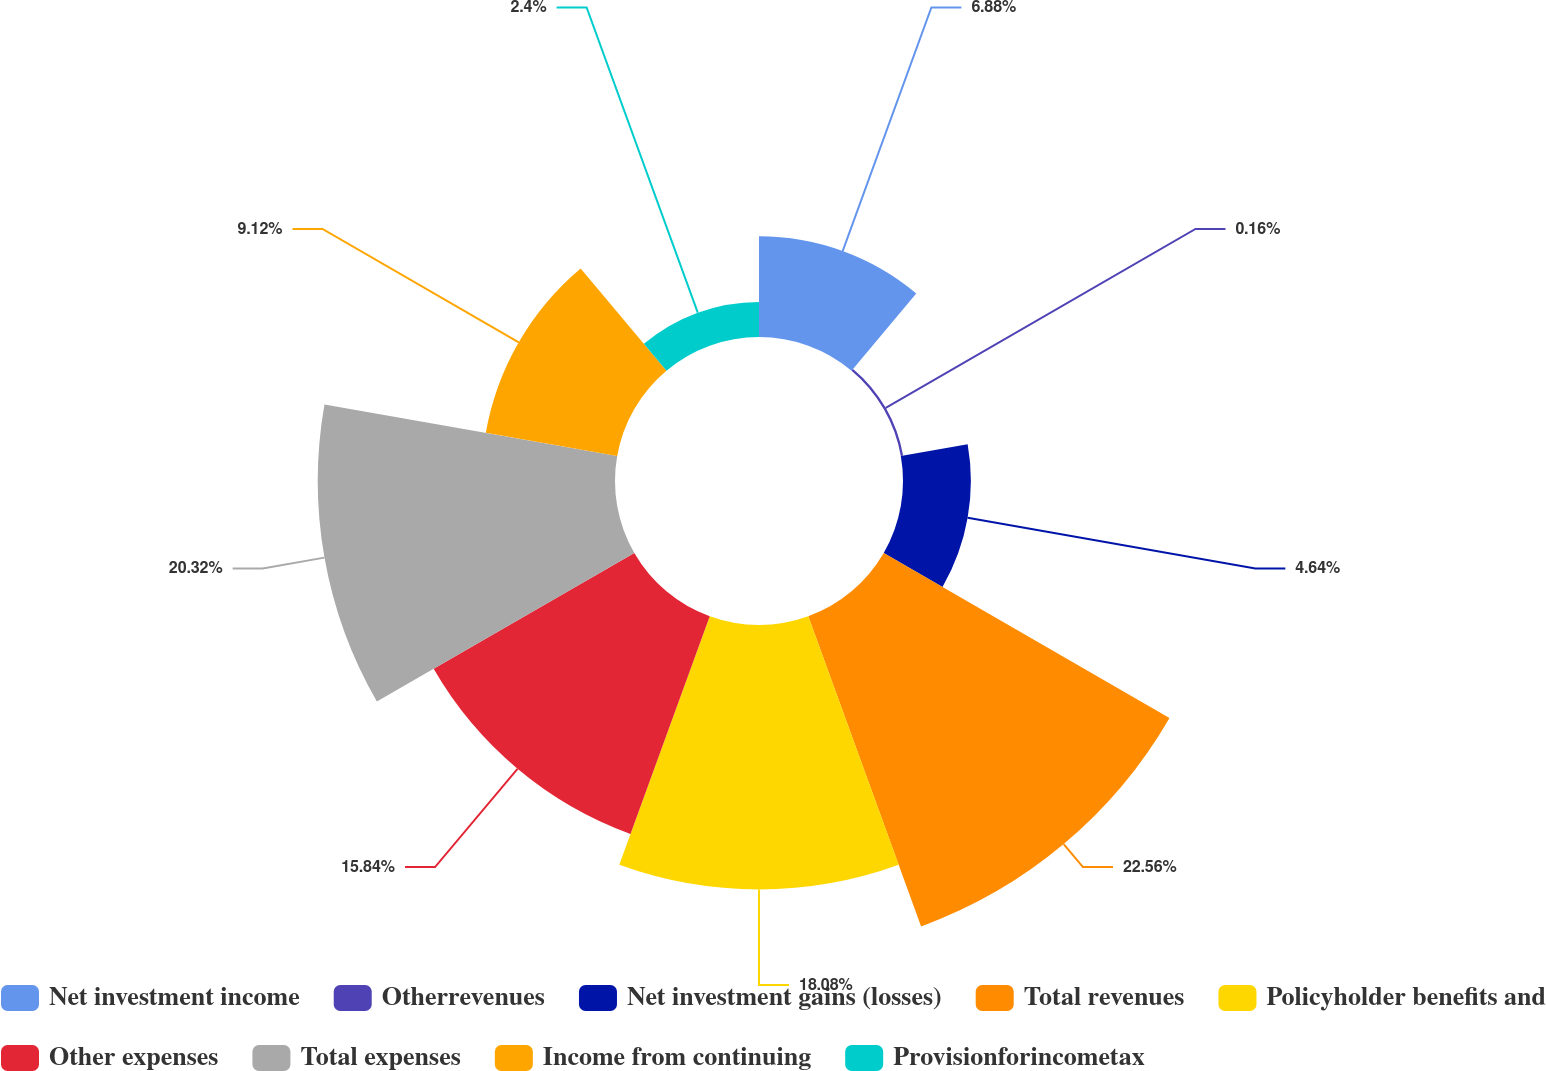<chart> <loc_0><loc_0><loc_500><loc_500><pie_chart><fcel>Net investment income<fcel>Otherrevenues<fcel>Net investment gains (losses)<fcel>Total revenues<fcel>Policyholder benefits and<fcel>Other expenses<fcel>Total expenses<fcel>Income from continuing<fcel>Provisionforincometax<nl><fcel>6.88%<fcel>0.16%<fcel>4.64%<fcel>22.56%<fcel>18.08%<fcel>15.84%<fcel>20.32%<fcel>9.12%<fcel>2.4%<nl></chart> 